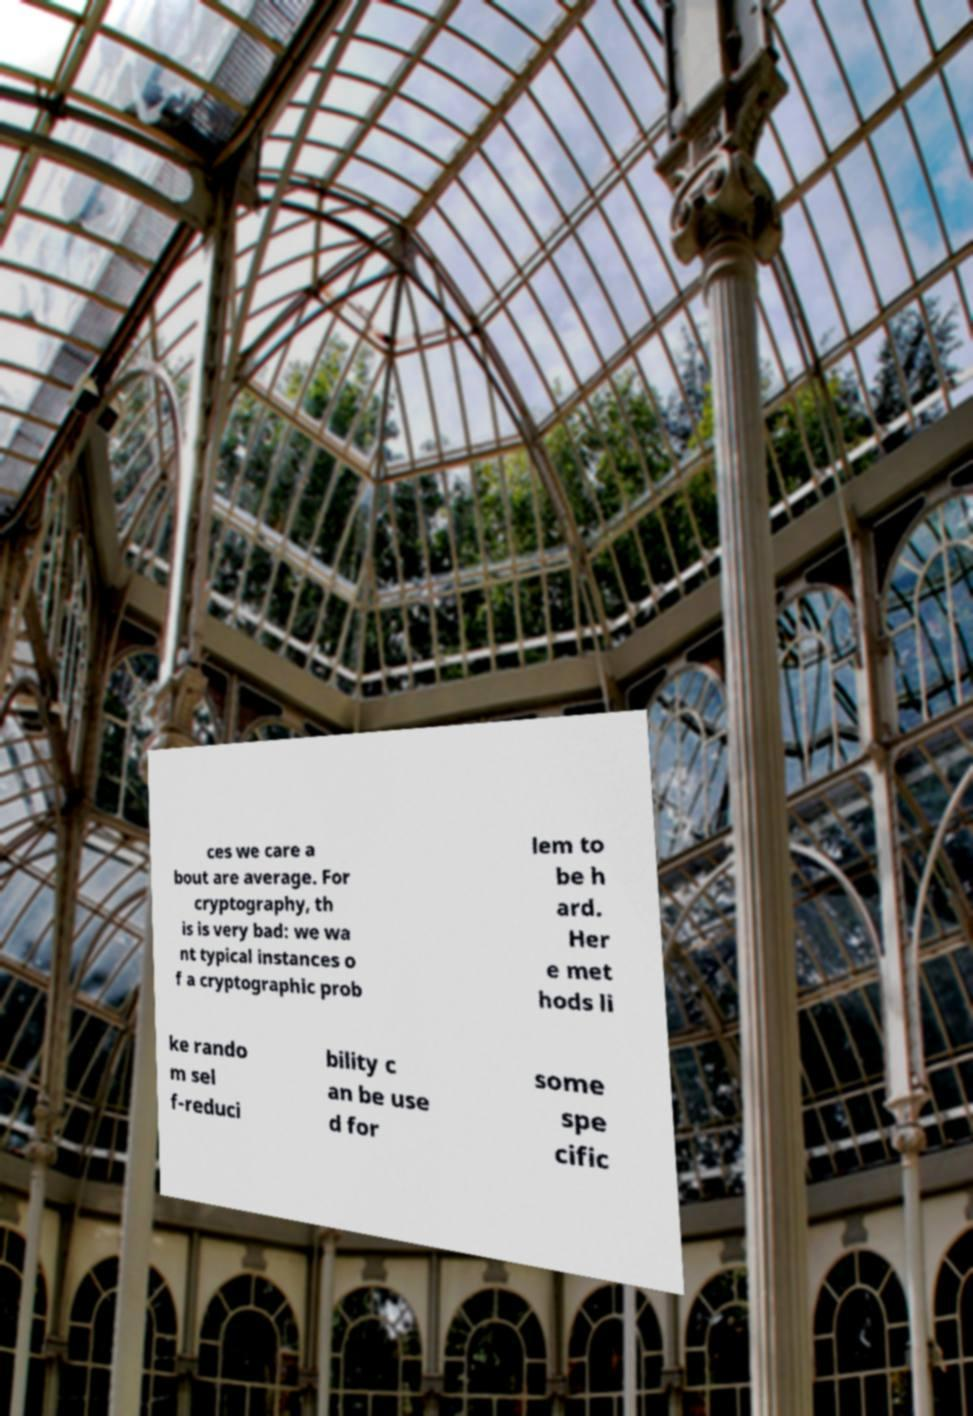Could you assist in decoding the text presented in this image and type it out clearly? ces we care a bout are average. For cryptography, th is is very bad: we wa nt typical instances o f a cryptographic prob lem to be h ard. Her e met hods li ke rando m sel f-reduci bility c an be use d for some spe cific 